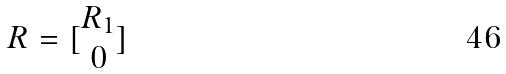Convert formula to latex. <formula><loc_0><loc_0><loc_500><loc_500>R = [ \begin{matrix} R _ { 1 } \\ 0 \end{matrix} ]</formula> 